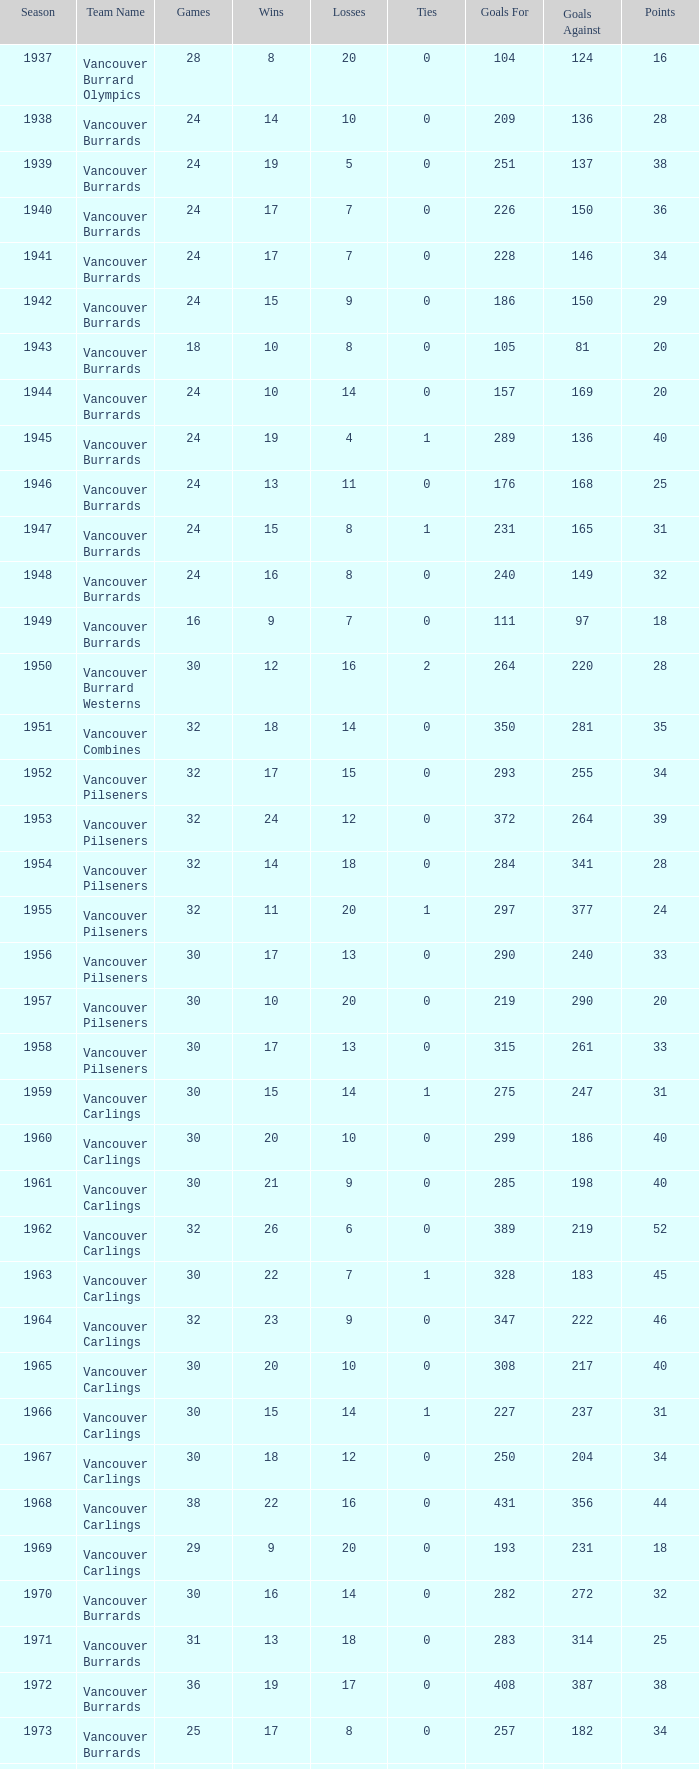What's the total number of points when the vancouver carlings have fewer than 12 losses and more than 32 games? 0.0. 